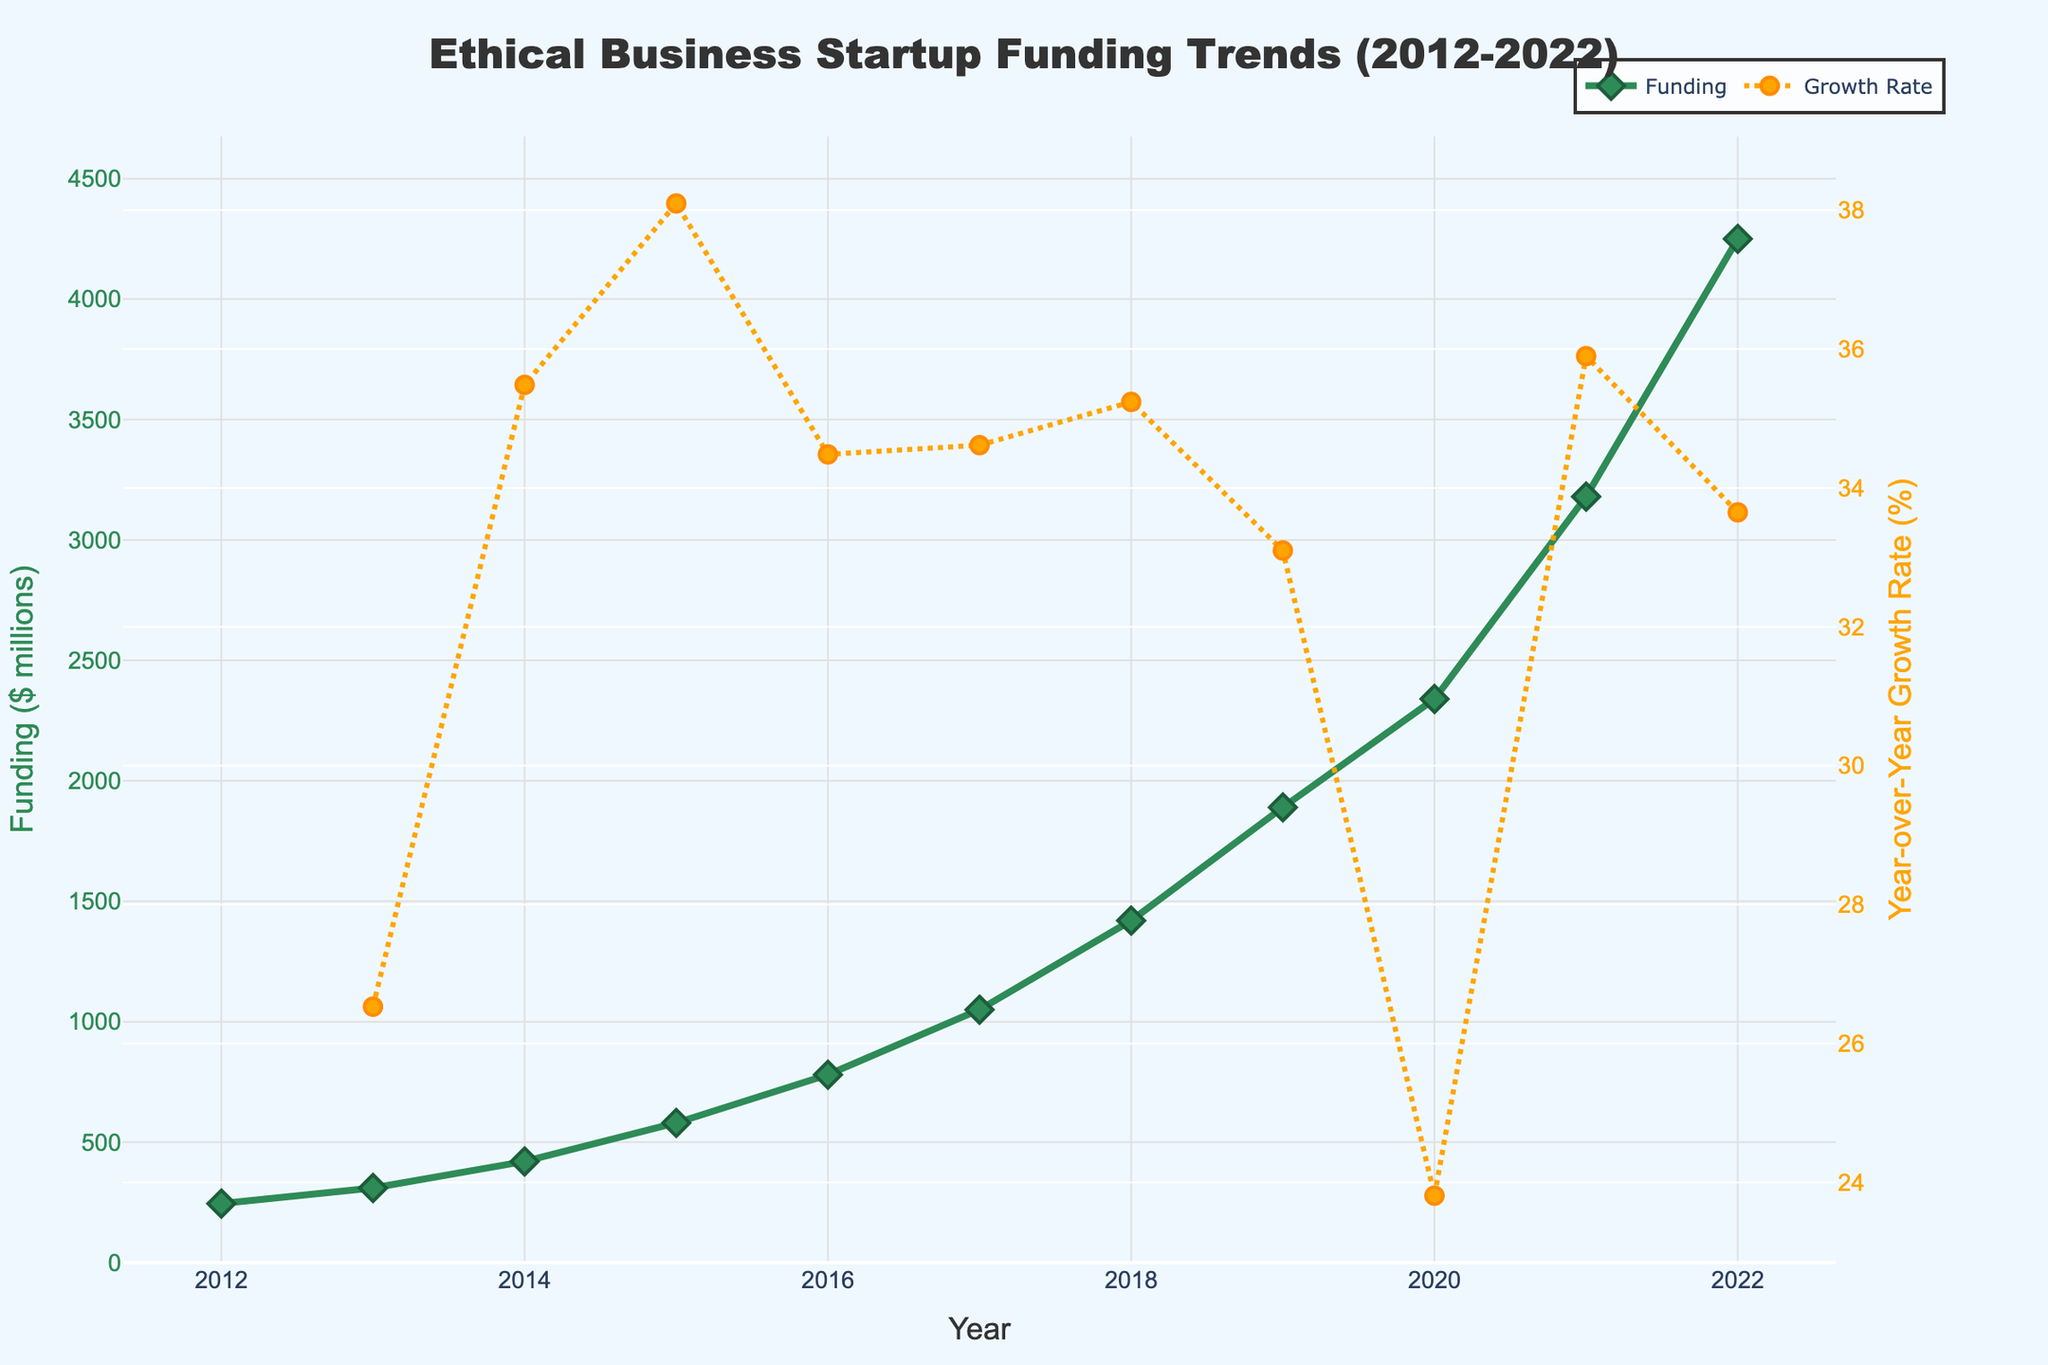What's the total funding for ethical business startups from 2012 to 2022? Sum the funding for each year from 2012 to 2022: 245 + 310 + 420 + 580 + 780 + 1050 + 1420 + 1890 + 2340 + 3180 + 4250. The total is 15465.
Answer: 15465 Which year saw the highest funding for ethical business startups? Look at the line chart and identify the peak point. The highest funding is in 2022 at $4250 million.
Answer: 2022 What was the year-over-year growth rate in funding from 2019 to 2020? Find the growth rate represented by the second line in the chart. For 2020, it's approximately 23.8%.
Answer: 23.8% Which two consecutive years had the highest jump in funding? Look for the steepest increase between two consecutive points on the funding line. The largest jump is from 2021 to 2022, where funding increased from $3180 million to $4250 million.
Answer: 2021 to 2022 What was the average funding between 2015 and 2019? Sum the funding for 2015, 2016, 2017, 2018, 2019 (580 + 780 + 1050 + 1420 + 1890), then divide by 5. The average is (580 + 780 + 1050 + 1420 + 1890)/5 = 1124.
Answer: 1124 Compare the funding in 2015 and 2018. Which year had higher funding and by how much? Funding in 2015 is $580 million, and in 2018 is $1420 million. The difference is 1420 - 580 = 840. So, 2018 is higher by $840 million.
Answer: 2018 by $840 million What's the percentage increase in funding from 2012 to 2016? Calculate the percentage increase using the formula: ((780 - 245)/245) * 100. The percentage increase is approximately 218.4%.
Answer: 218.4% Which year had the lowest growth rate in funding? Find the year where the growth rate line reaches the lowest point. The lowest growth rate is in 2014.
Answer: 2014 How does the growth rate in 2020 compare to the growth rate in 2019? Compare the values of growth rate lines in 2019 and 2020. The growth rate in 2020 (~23.8%) is higher compared to 2019 (~33.0%).
Answer: lower in 2020 What is the median funding value from 2012 to 2022? List the funding values, sort them, and find the middle value. Sorted values are: 245, 310, 420, 580, 780, 1050, 1420, 1890, 2340, 3180, 4250. The median value is 1050.
Answer: 1050 